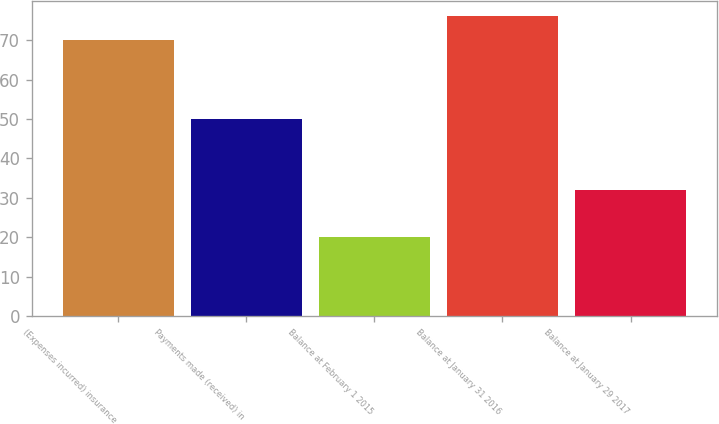Convert chart to OTSL. <chart><loc_0><loc_0><loc_500><loc_500><bar_chart><fcel>(Expenses incurred) insurance<fcel>Payments made (received) in<fcel>Balance at February 1 2015<fcel>Balance at January 31 2016<fcel>Balance at January 29 2017<nl><fcel>70<fcel>50<fcel>20<fcel>76<fcel>32<nl></chart> 